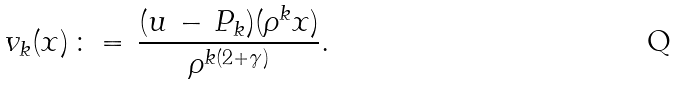<formula> <loc_0><loc_0><loc_500><loc_500>v _ { k } ( x ) \, \colon = \, \frac { ( u \, - \, P _ { k } ) ( \rho ^ { k } x ) } { \rho ^ { k ( 2 + \gamma ) } } .</formula> 